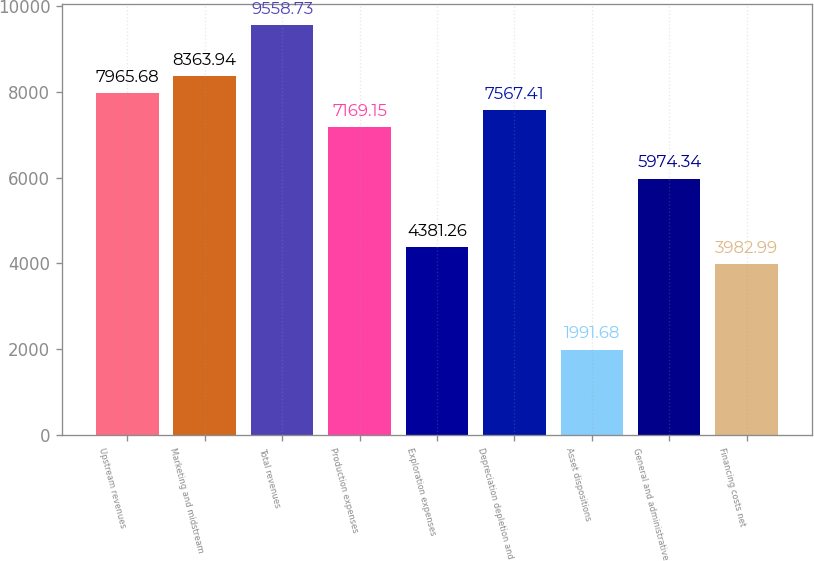Convert chart. <chart><loc_0><loc_0><loc_500><loc_500><bar_chart><fcel>Upstream revenues<fcel>Marketing and midstream<fcel>Total revenues<fcel>Production expenses<fcel>Exploration expenses<fcel>Depreciation depletion and<fcel>Asset dispositions<fcel>General and administrative<fcel>Financing costs net<nl><fcel>7965.68<fcel>8363.94<fcel>9558.73<fcel>7169.15<fcel>4381.26<fcel>7567.41<fcel>1991.68<fcel>5974.34<fcel>3982.99<nl></chart> 